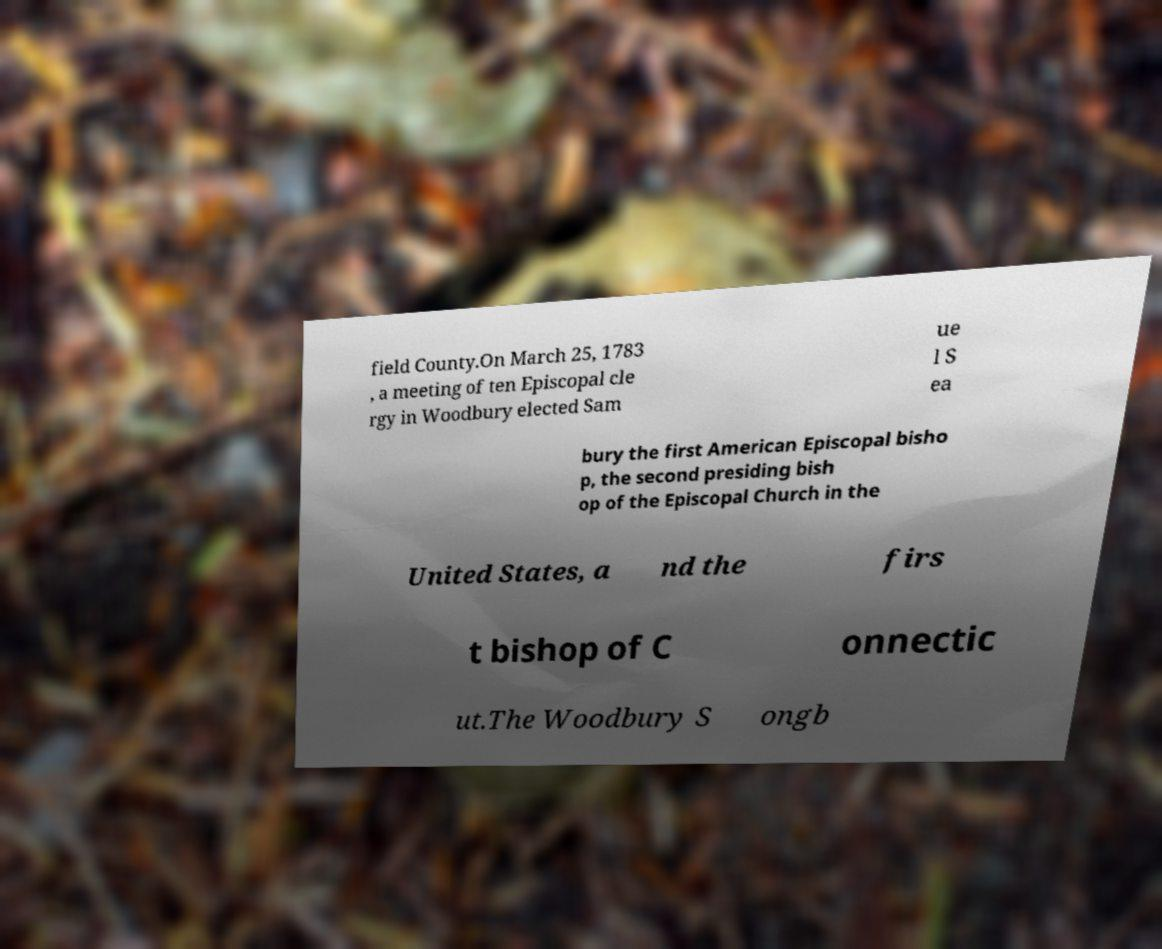Could you extract and type out the text from this image? field County.On March 25, 1783 , a meeting of ten Episcopal cle rgy in Woodbury elected Sam ue l S ea bury the first American Episcopal bisho p, the second presiding bish op of the Episcopal Church in the United States, a nd the firs t bishop of C onnectic ut.The Woodbury S ongb 